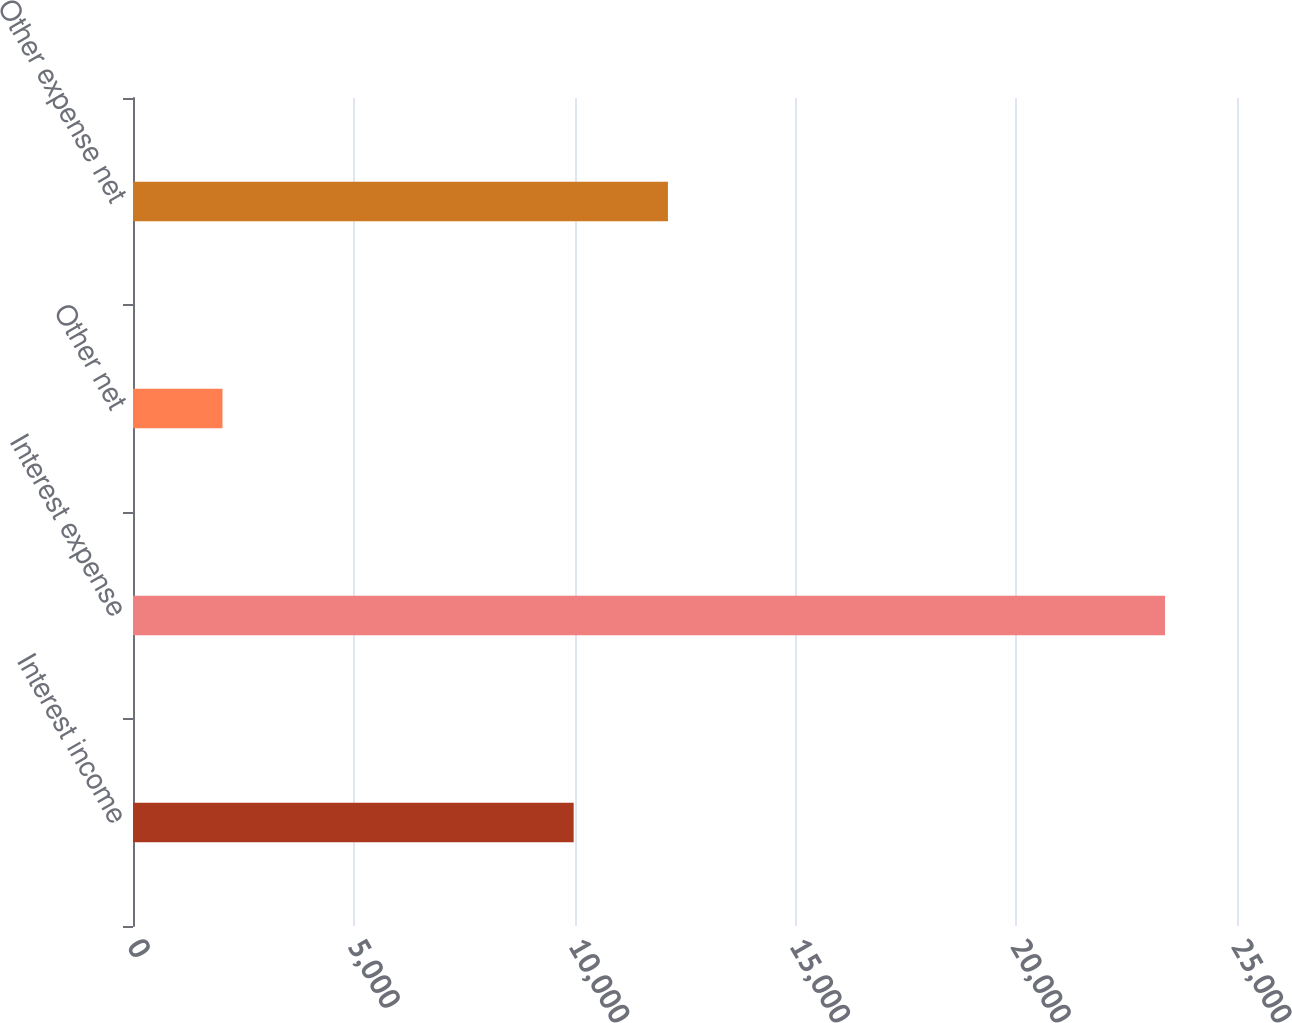Convert chart. <chart><loc_0><loc_0><loc_500><loc_500><bar_chart><fcel>Interest income<fcel>Interest expense<fcel>Other net<fcel>Other expense net<nl><fcel>9979<fcel>23370<fcel>2026<fcel>12113.4<nl></chart> 